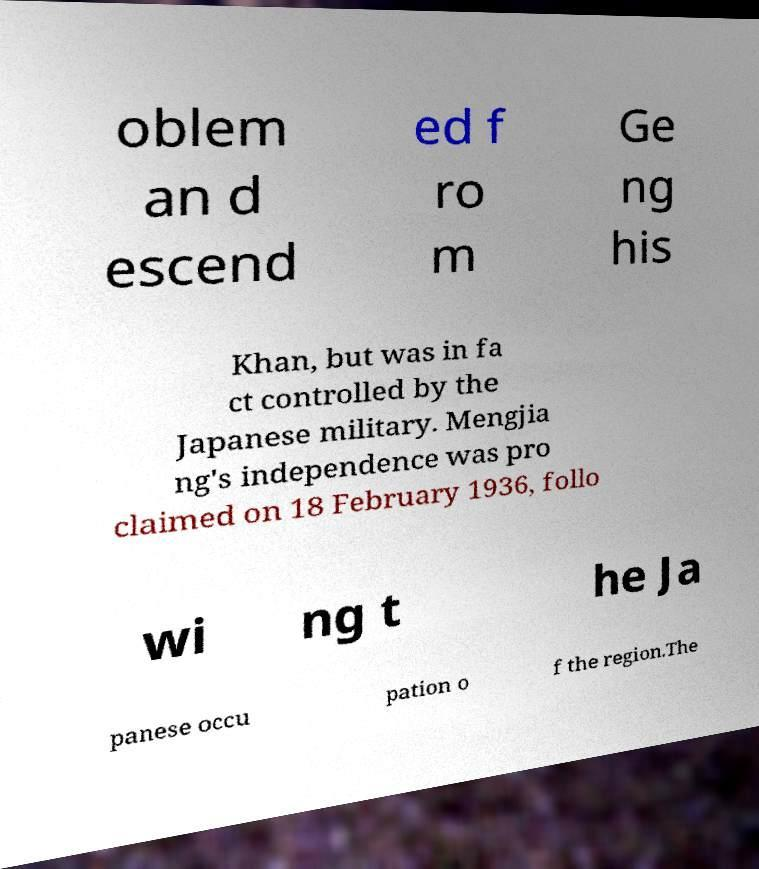There's text embedded in this image that I need extracted. Can you transcribe it verbatim? oblem an d escend ed f ro m Ge ng his Khan, but was in fa ct controlled by the Japanese military. Mengjia ng's independence was pro claimed on 18 February 1936, follo wi ng t he Ja panese occu pation o f the region.The 